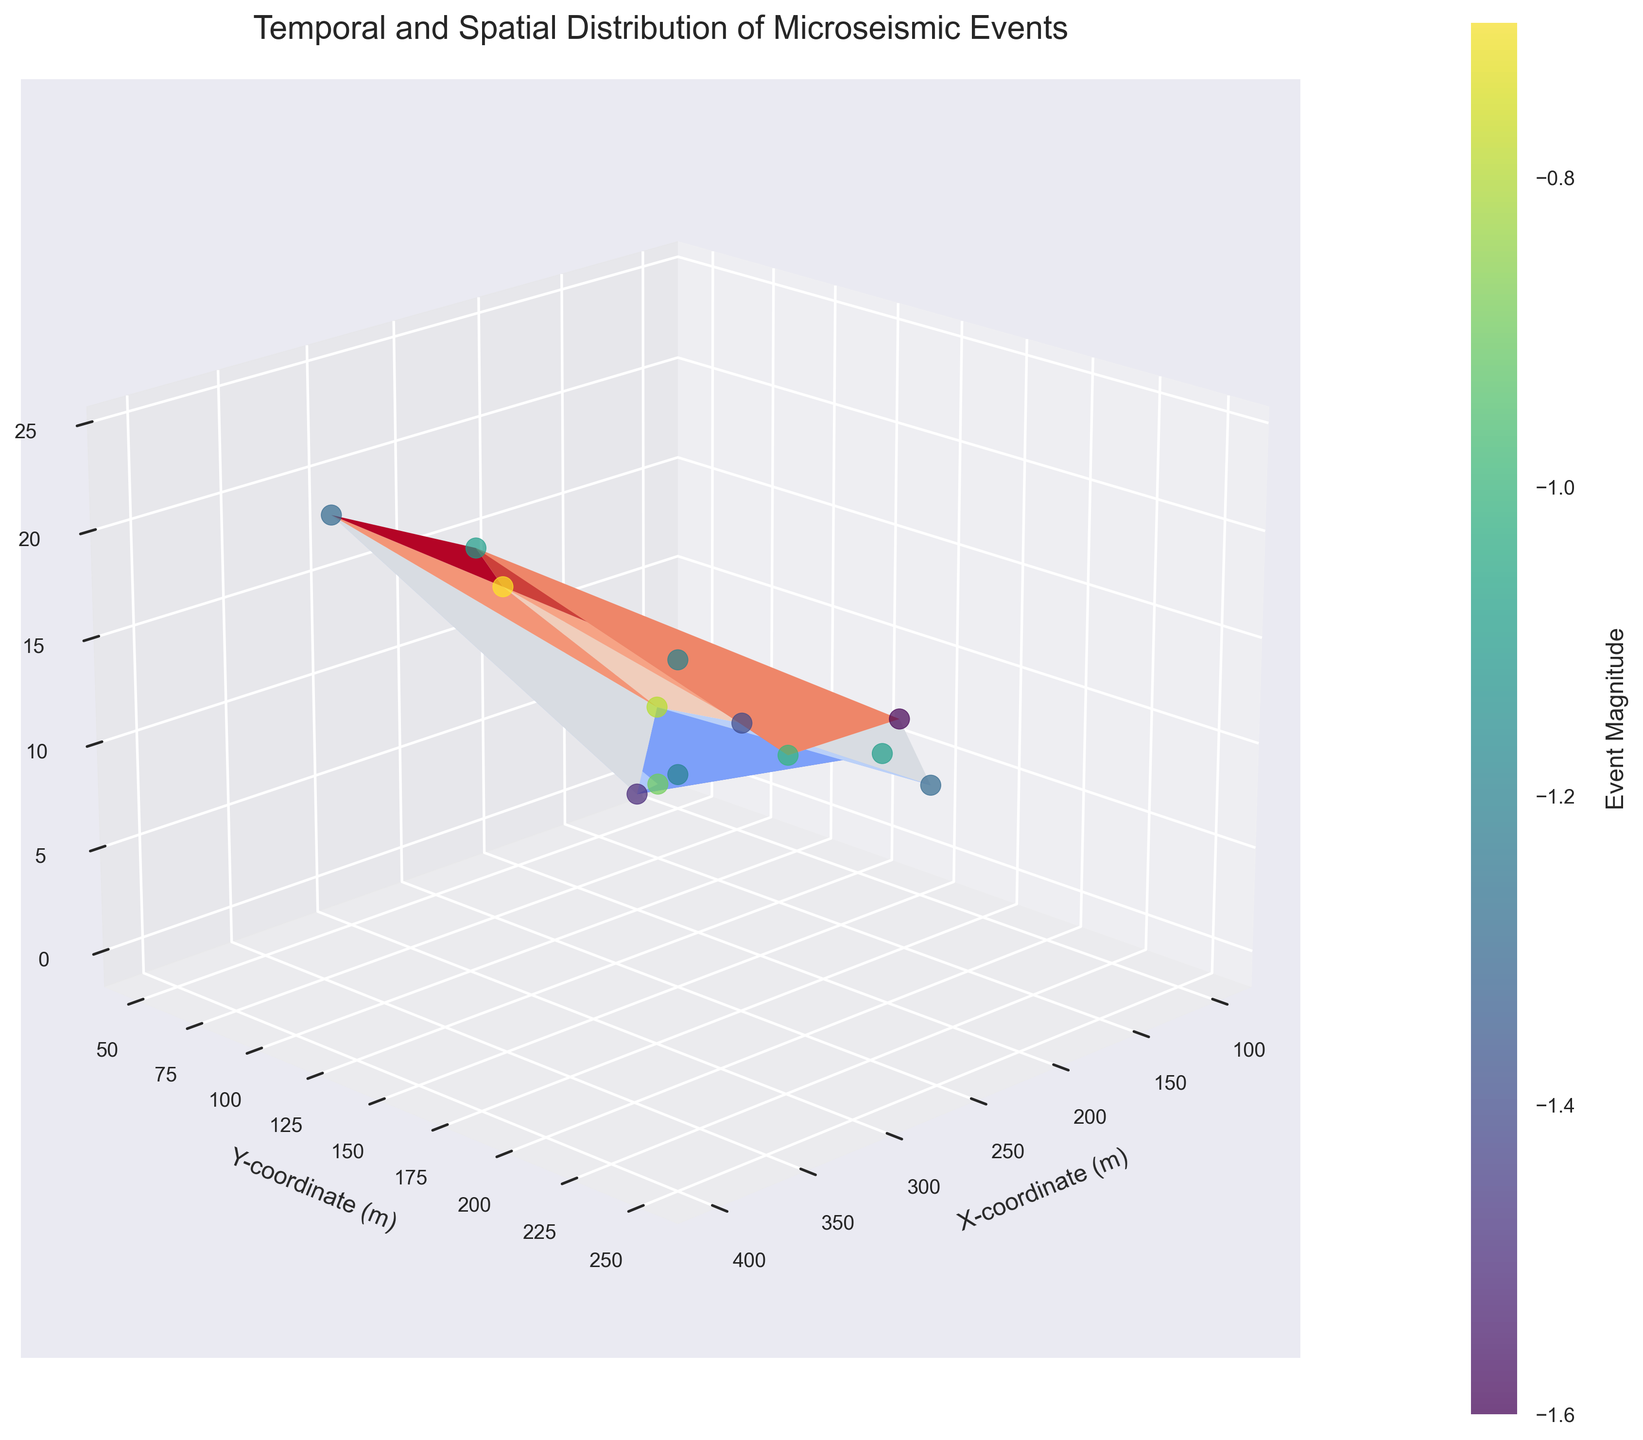What's the title of the figure? The title of the figure is displayed prominently at the top of the plot. In this case, it indicates "Temporal and Spatial Distribution of Microseismic Events".
Answer: Temporal and Spatial Distribution of Microseismic Events What are the three axes labeled in the plot? The labels on the three axes describe the dimensions being plotted. They are 'X-coordinate (m)', 'Y-coordinate (m)', and 'Time (hours)'.
Answer: X-coordinate (m), Y-coordinate (m), Time (hours) How many data points are plotted in the figure? By examining the number of scatter points on the figure, we can count that there are 13 data points representing microseismic events.
Answer: 13 Which microseismic event occurred at the highest point in time? By inspecting the 'Time (hours)' axis and identifying the highest value, we can see that the event at (400, 175) occurred at 24 hours.
Answer: (400, 175), 24 hours Which event has the lowest magnitude, and what are its coordinates? By observing the color scale and scatter points, the event with the lowest magnitude (darkest color on the viridis scale) can be found at the coordinates (275, 250) with a magnitude of -1.6.
Answer: (275, 250), -1.6 Is there a general trend in microseismic event magnitudes over time? By examining the color gradients over time, it’s noticeable that there isn't a clear trend of increasing or decreasing magnitudes; the event magnitudes vary over time without a discernible pattern.
Answer: No clear trend What is the magnitude of the event located at (350, 150)? By locating the coordinates (350, 150) on the figure and matching the color of the scatter point to the color bar, the event magnitude can be determined to be -0.7.
Answer: -0.7 Which event occurred first and what is its magnitude? The earliest event can be identified by looking at the lowest value on the 'Time (hours)' axis, which is at (100, 50) with a magnitude of -1.2.
Answer: (100, 50), -1.2 How does the elevation angle (viewing angle) of the 3D plot contribute to understanding the data? The elevation angle of 20 degrees allows a clear view of the distribution along the 'Time (hours)' axis, while the azimuthal angle of 45 degrees gives a balanced perspective of spatial distribution. This combination makes it easier to discern how the events are spread across the three dimensions.
Answer: Clearer view of distribution across time and space Are there any data points that have similar X and Y coordinates but occur at significantly different times? Yes, by comparing the X and Y coordinates of the points, events at (175, 200) and (325, 200) have similar Y coordinates but occur at 8 and 18 hours, respectively.
Answer: (175, 200) at 8 hours and (325, 200) at 18 hours 